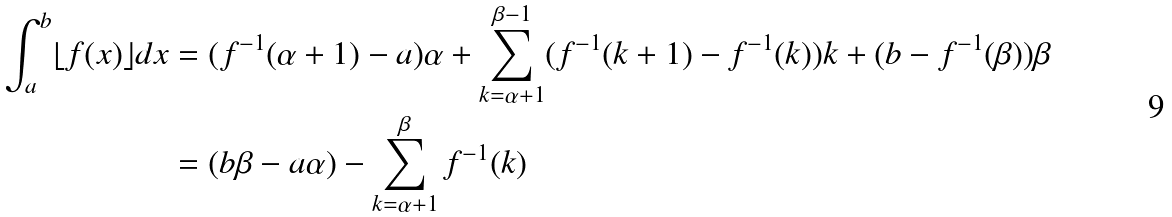Convert formula to latex. <formula><loc_0><loc_0><loc_500><loc_500>\int _ { a } ^ { b } \lfloor f ( x ) \rfloor d x & = ( f ^ { - 1 } ( \alpha + 1 ) - a ) \alpha + \sum _ { k = \alpha + 1 } ^ { \beta - 1 } ( f ^ { - 1 } ( k + 1 ) - f ^ { - 1 } ( k ) ) k + ( b - f ^ { - 1 } ( \beta ) ) \beta \\ & = ( b \beta - a \alpha ) - \sum _ { k = \alpha + 1 } ^ { \beta } f ^ { - 1 } ( k )</formula> 